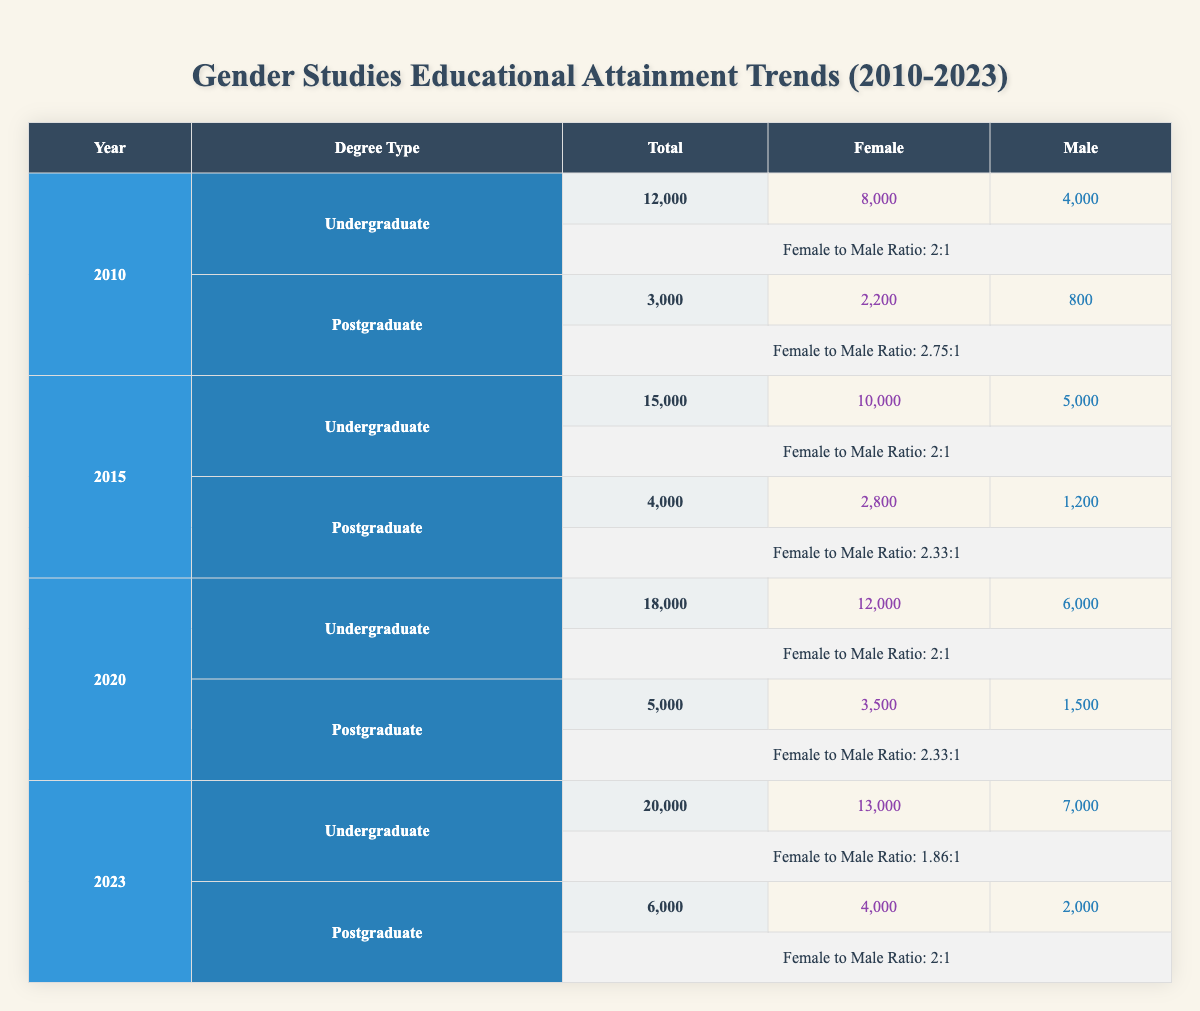What is the total number of undergraduate degrees awarded in 2010? The table shows that in 2010, the total number of undergraduate degrees awarded in Gender Studies was 12,000.
Answer: 12,000 What was the ratio of female to male undergraduate degrees awarded in 2015? In 2015, the number of female undergraduate degrees was 10,000 and male degrees were 5,000. To find the ratio, we compare these numbers: 10,000/5,000 = 2, so the ratio is 2:1.
Answer: 2:1 How many more postgraduate degrees were awarded in 2023 than in 2010? In 2023, the total number of postgraduate degrees was 6,000 and in 2010, it was 3,000. To find the difference, we subtract: 6,000 - 3,000 = 3,000.
Answer: 3,000 Did the proportion of male to female postgraduate degrees awarded in 2015 exceed the proportion in 2020? In 2015, the female postgraduate degree count was 2,800 and male count was 1,200, leading to a ratio of 2.33:1. In 2020, the female count was 3,500 and the male count was 1,500, giving a ratio of 2.33:1 as well. Since both are equal, the proportion did not exceed.
Answer: No What was the increase in the total number of undergraduate degrees from 2020 to 2023? The total number of undergraduate degrees in 2020 was 18,000 and in 2023 it increased to 20,000. To find the increase, we subtract these two values: 20,000 - 18,000 = 2,000.
Answer: 2,000 What percentage of total undergraduate degrees in 2023 were awarded to females? The total number of undergraduate degrees in 2023 is 20,000, with 13,000 awarded to females. To find the percentage, we calculate (13,000/20,000) x 100 = 65%.
Answer: 65% How many postgraduate degrees were awarded to males in 2020 and 2023 combined? In 2020, the number of postgraduate degrees awarded to males was 1,500 and in 2023 it was 2,000. To find the total for both years, we sum these numbers: 1,500 + 2,000 = 3,500.
Answer: 3,500 In which year did female undergraduate degrees reach their highest amount? By examining the data, we see that female undergraduate degrees peaked in 2023 with a total of 13,000 awarded.
Answer: 2023 